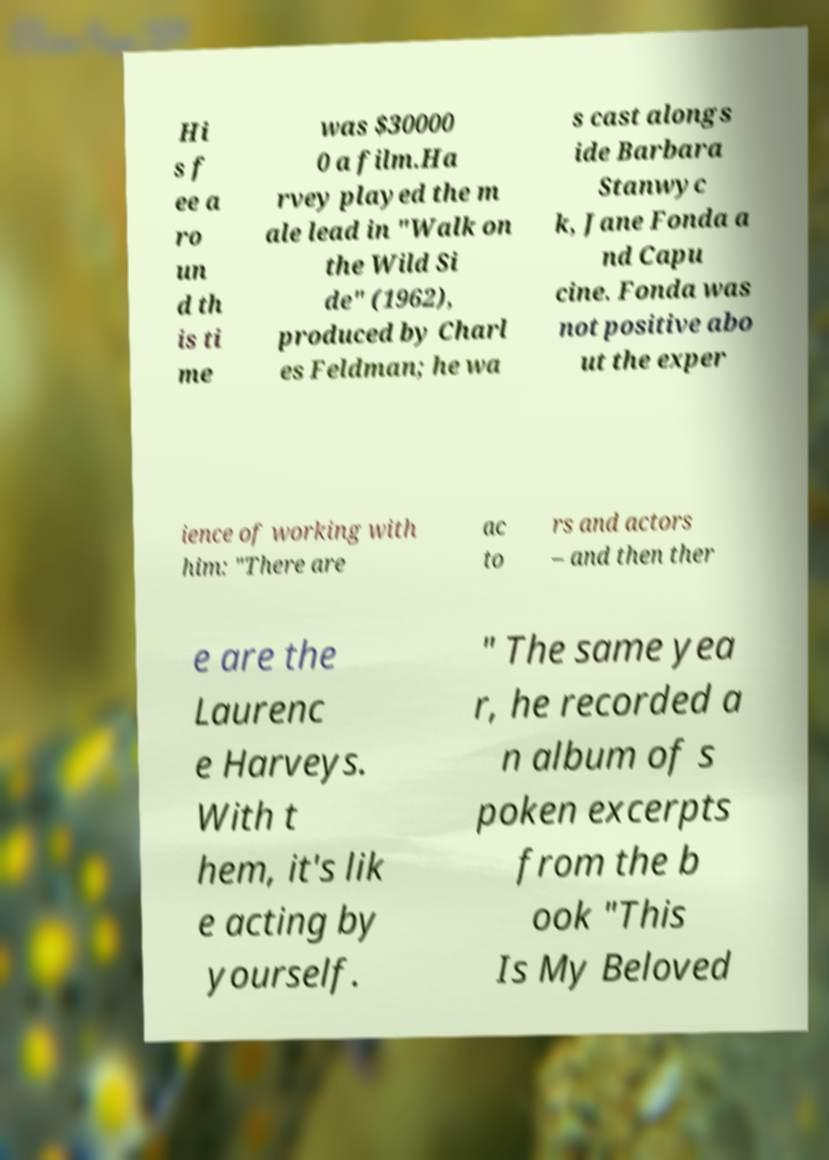For documentation purposes, I need the text within this image transcribed. Could you provide that? Hi s f ee a ro un d th is ti me was $30000 0 a film.Ha rvey played the m ale lead in "Walk on the Wild Si de" (1962), produced by Charl es Feldman; he wa s cast alongs ide Barbara Stanwyc k, Jane Fonda a nd Capu cine. Fonda was not positive abo ut the exper ience of working with him: "There are ac to rs and actors – and then ther e are the Laurenc e Harveys. With t hem, it's lik e acting by yourself. " The same yea r, he recorded a n album of s poken excerpts from the b ook "This Is My Beloved 